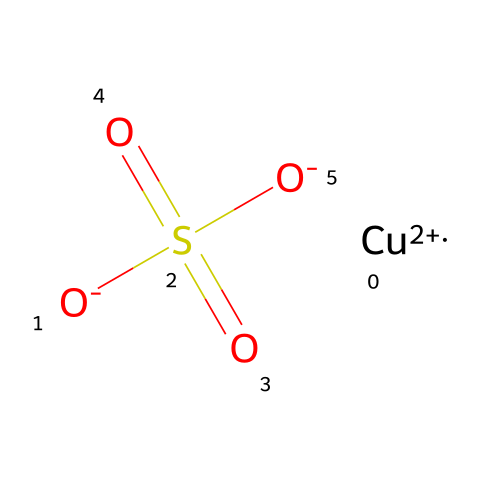What is the oxidation state of copper in copper sulfate? In the chemical representation, copper is indicated as [Cu+2], which shows that it has an oxidation state of +2.
Answer: +2 How many oxygen atoms are present in copper sulfate? The chemical structure contains three oxygen atoms, two from the sulfate ion (S(=O)(=O)[O-]) and one as part of the compound with copper.
Answer: 3 What is the chemical classification of copper sulfate? Given that copper sulfate is used as a fungicide and is composed of a metal and a sulfate group, it is classified as an inorganic pesticide.
Answer: inorganic pesticide What is the total number of atoms in copper sulfate? The total number of atoms can be calculated by counting: 1 copper (Cu), 1 sulfur (S), and 4 oxygen (O) atoms, totaling 6 atoms.
Answer: 6 How does the sulfur in copper sulfate contribute to its function as a fungicide? Sulfur contributes to its function by being part of the sulfate ion, which is known to have antifungal properties, thereby inhibiting fungal growth.
Answer: antifungal properties What type of bonding is present in the copper sulfate structure? Copper sulfate exhibits ionic bonding between copper ions and sulfate ions, as indicated by the presence of charged species in the chemical structure.
Answer: ionic bonding 